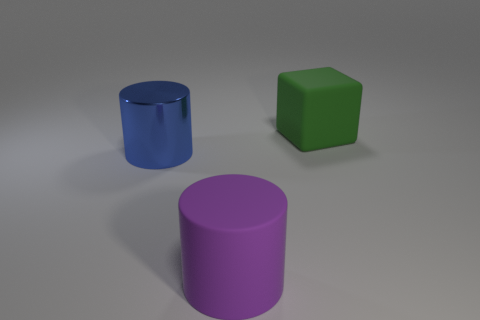Are there any yellow shiny objects that have the same shape as the blue thing?
Provide a short and direct response. No. There is a matte object that is left of the large matte thing right of the big rubber thing that is in front of the large cube; what size is it?
Make the answer very short. Large. Are there an equal number of things that are right of the purple rubber thing and large matte objects that are to the right of the big rubber cube?
Offer a terse response. No. What size is the purple cylinder that is made of the same material as the big green thing?
Provide a succinct answer. Large. The large metallic object has what color?
Offer a very short reply. Blue. What is the material of the other green object that is the same size as the shiny thing?
Offer a terse response. Rubber. There is a big cylinder right of the metal object; are there any large things that are behind it?
Offer a terse response. Yes. How many other things are the same color as the large metallic object?
Your answer should be compact. 0. What is the size of the blue shiny cylinder?
Give a very brief answer. Large. Is there a purple metallic object?
Give a very brief answer. No. 